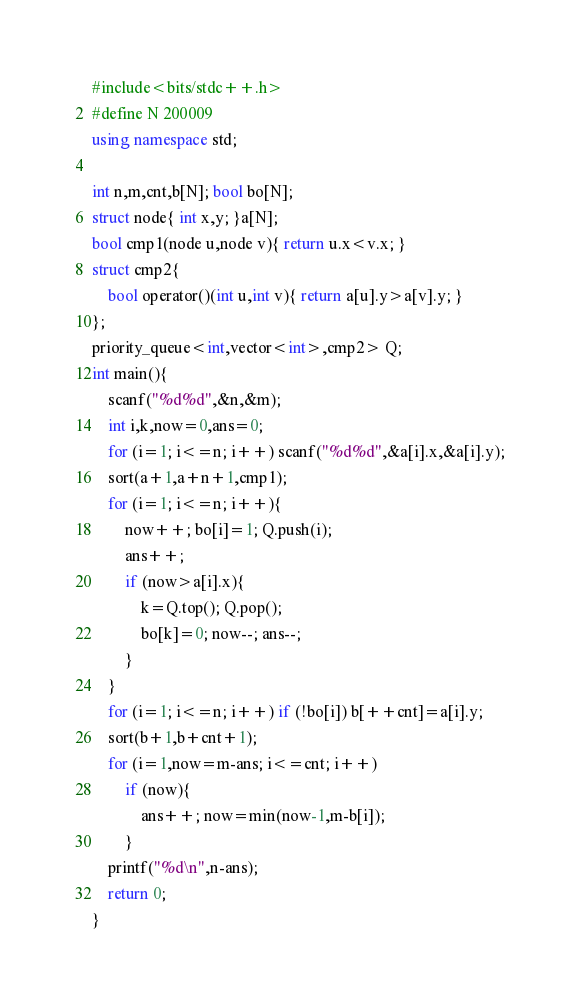Convert code to text. <code><loc_0><loc_0><loc_500><loc_500><_C++_>#include<bits/stdc++.h>
#define N 200009
using namespace std;

int n,m,cnt,b[N]; bool bo[N];
struct node{ int x,y; }a[N];
bool cmp1(node u,node v){ return u.x<v.x; }
struct cmp2{
	bool operator()(int u,int v){ return a[u].y>a[v].y; }
};
priority_queue<int,vector<int>,cmp2> Q;
int main(){
	scanf("%d%d",&n,&m);
	int i,k,now=0,ans=0;
	for (i=1; i<=n; i++) scanf("%d%d",&a[i].x,&a[i].y);
	sort(a+1,a+n+1,cmp1);
	for (i=1; i<=n; i++){
		now++; bo[i]=1; Q.push(i);
		ans++;
		if (now>a[i].x){
			k=Q.top(); Q.pop();
			bo[k]=0; now--; ans--;
		}
	}
	for (i=1; i<=n; i++) if (!bo[i]) b[++cnt]=a[i].y;
	sort(b+1,b+cnt+1);
	for (i=1,now=m-ans; i<=cnt; i++)
		if (now){
			ans++; now=min(now-1,m-b[i]);
		}
	printf("%d\n",n-ans);
	return 0;
}
</code> 